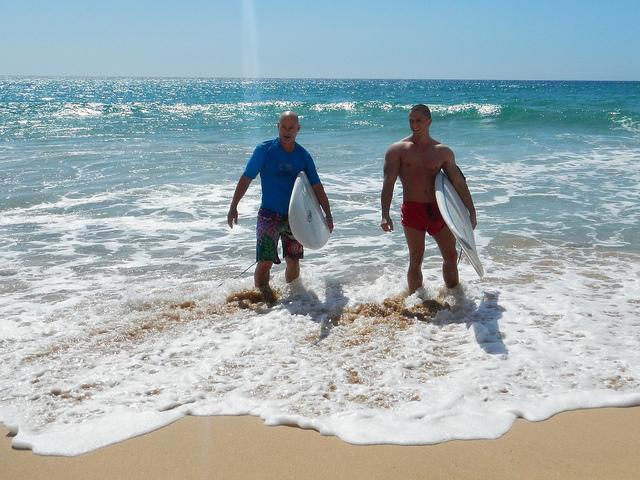How many men are shirtless?
Give a very brief answer. 1. How many people can you see?
Give a very brief answer. 2. 